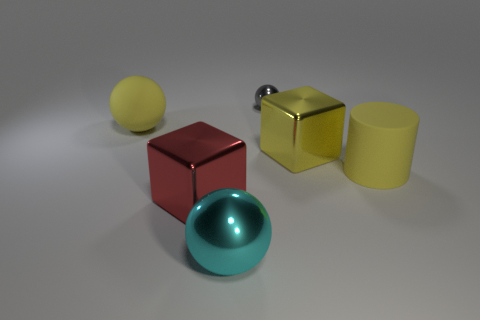Are there any large metal blocks of the same color as the cylinder?
Provide a succinct answer. Yes. What color is the other metallic block that is the same size as the yellow block?
Your answer should be compact. Red. Is the block that is in front of the matte cylinder made of the same material as the yellow sphere?
Offer a terse response. No. Are there any big cyan metal spheres to the left of the big block that is in front of the block that is behind the big red object?
Make the answer very short. No. Does the big yellow metal thing that is behind the cyan ball have the same shape as the red metallic object?
Provide a succinct answer. Yes. The rubber thing behind the matte thing right of the big red cube is what shape?
Your answer should be compact. Sphere. What size is the ball behind the matte object behind the big cube that is on the right side of the red metallic cube?
Provide a succinct answer. Small. What color is the other tiny metal object that is the same shape as the cyan object?
Your response must be concise. Gray. Do the red shiny thing and the gray metallic thing have the same size?
Give a very brief answer. No. There is a big sphere that is on the left side of the big cyan object; what material is it?
Offer a very short reply. Rubber. 